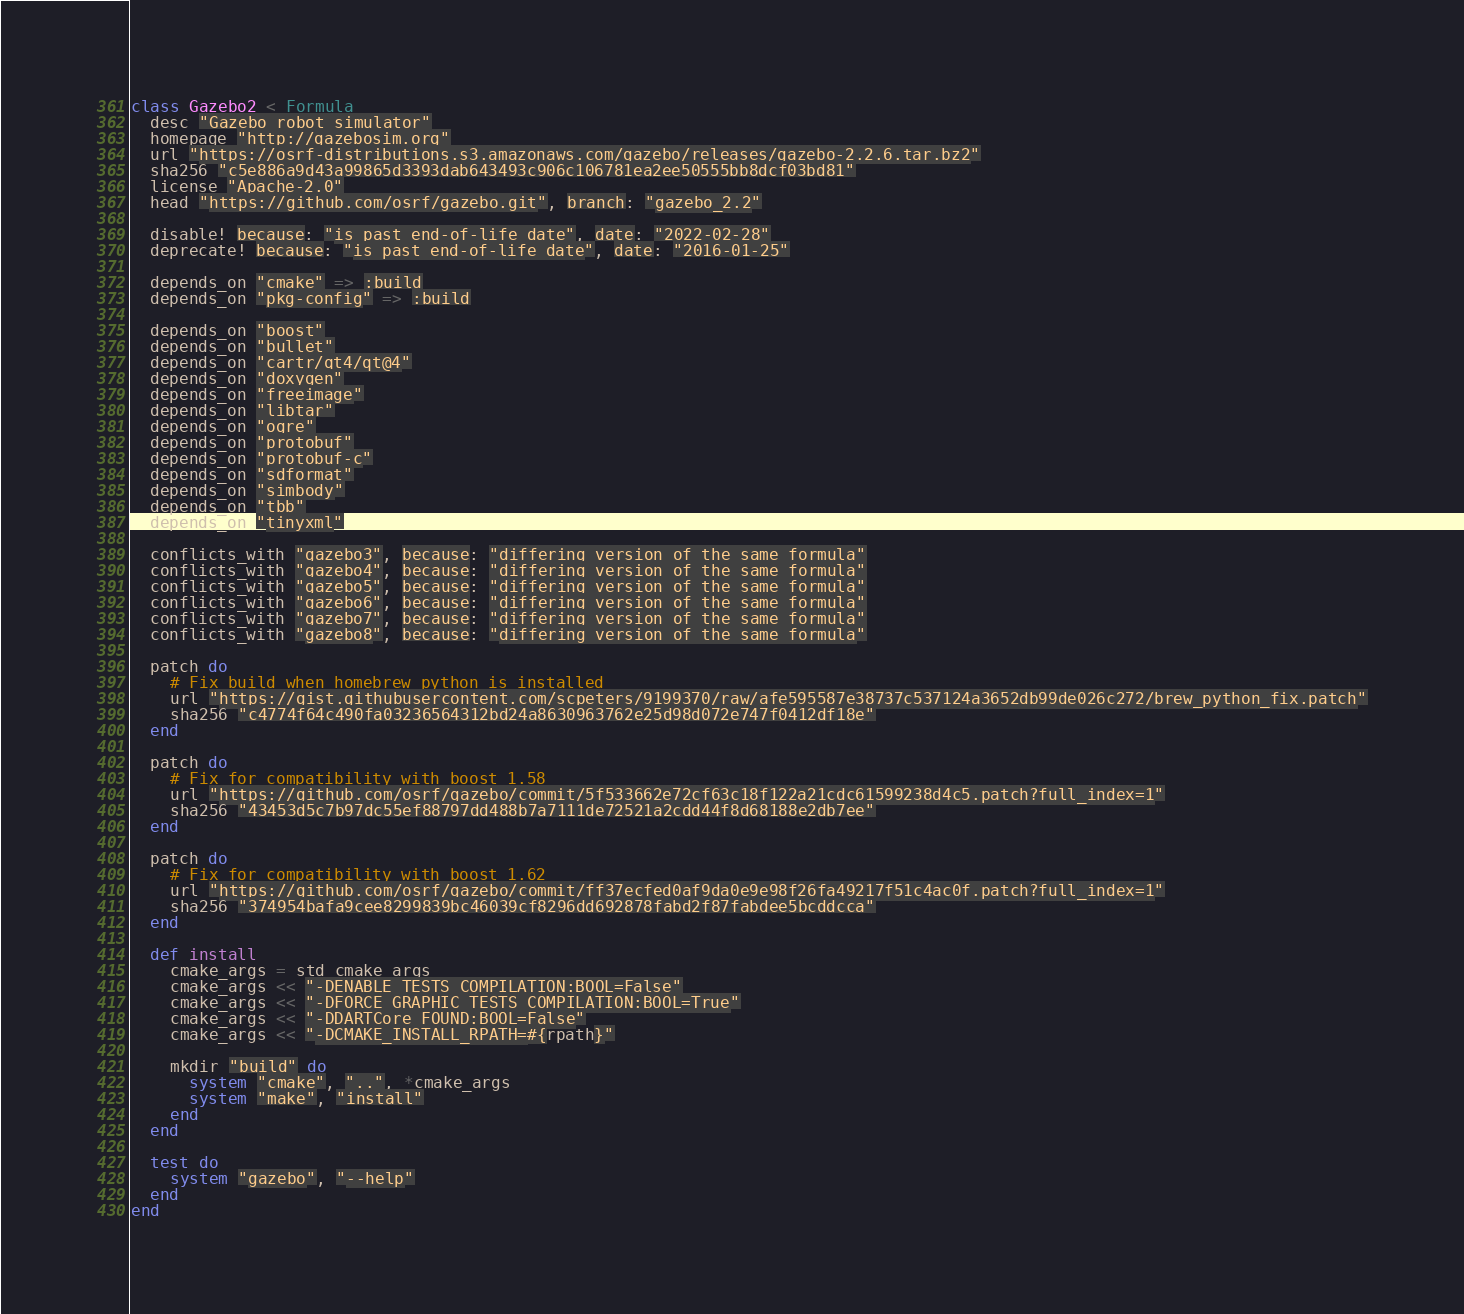<code> <loc_0><loc_0><loc_500><loc_500><_Ruby_>class Gazebo2 < Formula
  desc "Gazebo robot simulator"
  homepage "http://gazebosim.org"
  url "https://osrf-distributions.s3.amazonaws.com/gazebo/releases/gazebo-2.2.6.tar.bz2"
  sha256 "c5e886a9d43a99865d3393dab643493c906c106781ea2ee50555bb8dcf03bd81"
  license "Apache-2.0"
  head "https://github.com/osrf/gazebo.git", branch: "gazebo_2.2"

  disable! because: "is past end-of-life date", date: "2022-02-28"
  deprecate! because: "is past end-of-life date", date: "2016-01-25"

  depends_on "cmake" => :build
  depends_on "pkg-config" => :build

  depends_on "boost"
  depends_on "bullet"
  depends_on "cartr/qt4/qt@4"
  depends_on "doxygen"
  depends_on "freeimage"
  depends_on "libtar"
  depends_on "ogre"
  depends_on "protobuf"
  depends_on "protobuf-c"
  depends_on "sdformat"
  depends_on "simbody"
  depends_on "tbb"
  depends_on "tinyxml"

  conflicts_with "gazebo3", because: "differing version of the same formula"
  conflicts_with "gazebo4", because: "differing version of the same formula"
  conflicts_with "gazebo5", because: "differing version of the same formula"
  conflicts_with "gazebo6", because: "differing version of the same formula"
  conflicts_with "gazebo7", because: "differing version of the same formula"
  conflicts_with "gazebo8", because: "differing version of the same formula"

  patch do
    # Fix build when homebrew python is installed
    url "https://gist.githubusercontent.com/scpeters/9199370/raw/afe595587e38737c537124a3652db99de026c272/brew_python_fix.patch"
    sha256 "c4774f64c490fa03236564312bd24a8630963762e25d98d072e747f0412df18e"
  end

  patch do
    # Fix for compatibility with boost 1.58
    url "https://github.com/osrf/gazebo/commit/5f533662e72cf63c18f122a21cdc61599238d4c5.patch?full_index=1"
    sha256 "43453d5c7b97dc55ef88797dd488b7a7111de72521a2cdd44f8d68188e2db7ee"
  end

  patch do
    # Fix for compatibility with boost 1.62
    url "https://github.com/osrf/gazebo/commit/ff37ecfed0af9da0e9e98f26fa49217f51c4ac0f.patch?full_index=1"
    sha256 "374954bafa9cee8299839bc46039cf8296dd692878fabd2f87fabdee5bcddcca"
  end

  def install
    cmake_args = std_cmake_args
    cmake_args << "-DENABLE_TESTS_COMPILATION:BOOL=False"
    cmake_args << "-DFORCE_GRAPHIC_TESTS_COMPILATION:BOOL=True"
    cmake_args << "-DDARTCore_FOUND:BOOL=False"
    cmake_args << "-DCMAKE_INSTALL_RPATH=#{rpath}"

    mkdir "build" do
      system "cmake", "..", *cmake_args
      system "make", "install"
    end
  end

  test do
    system "gazebo", "--help"
  end
end
</code> 